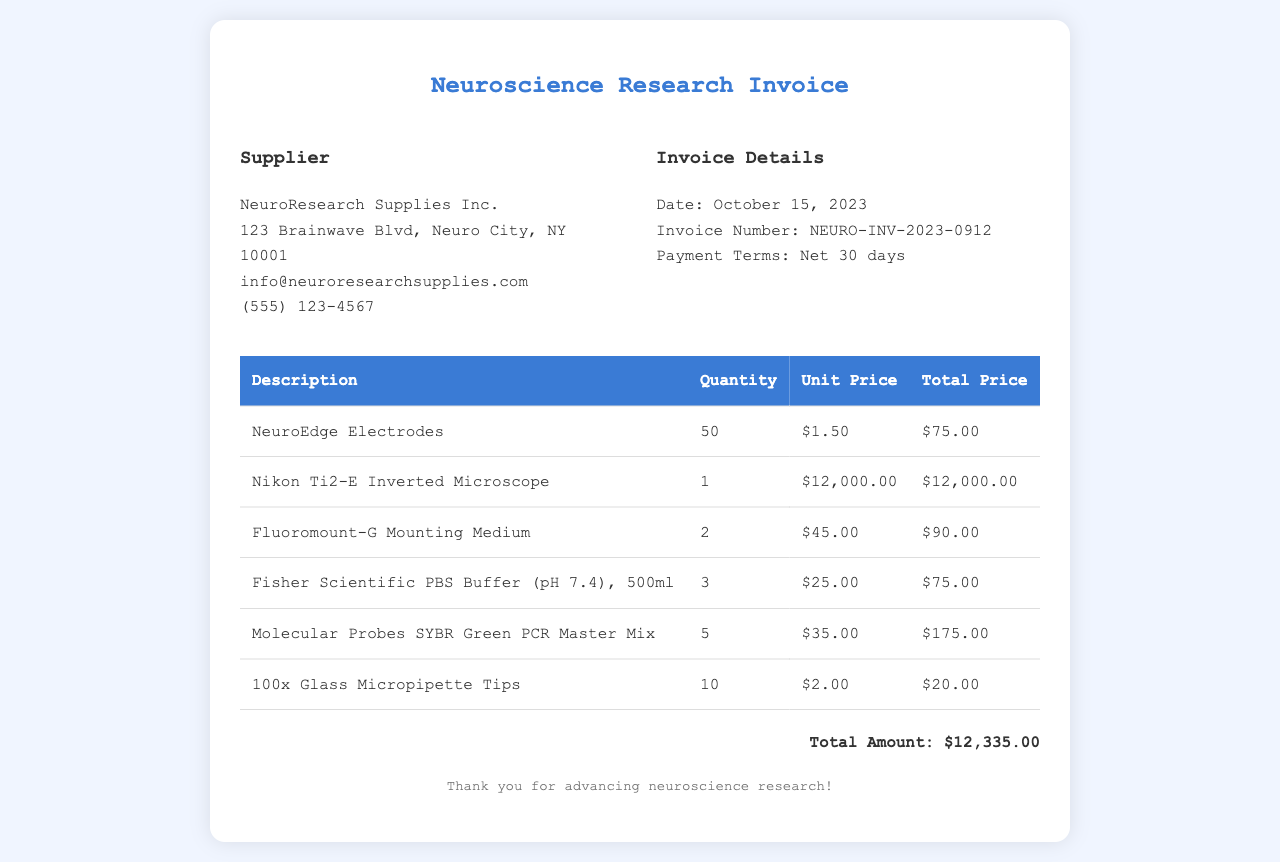What is the name of the supplier? The supplier's name is listed at the top of the document, under the supplier info section.
Answer: NeuroResearch Supplies Inc What is the invoice date? The invoice date can be found in the invoice info section of the document.
Answer: October 15, 2023 How many NeuroEdge Electrodes were purchased? The quantity of NeuroEdge Electrodes is specified in the table under the quantity column.
Answer: 50 What is the total amount of the invoice? The total amount is calculated at the bottom of the document after summing all items.
Answer: $12,335.00 What is the unit price of the Nikon Ti2-E Inverted Microscope? The unit price is indicated in the table next to the description of the microscope.
Answer: $12,000.00 How many different types of items are listed in the invoice? Counting the rows in the table provides the total number of different items purchased.
Answer: 6 What are the payment terms? The payment terms are noted in the invoice info section of the document.
Answer: Net 30 days What is the total price for the Molecular Probes SYBR Green PCR Master Mix? The total price for the PCR Master Mix can be found in the last column of the corresponding table row.
Answer: $175.00 